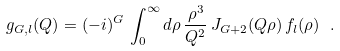Convert formula to latex. <formula><loc_0><loc_0><loc_500><loc_500>g _ { G , l } ( Q ) = ( - i ) ^ { G } \, \int _ { 0 } ^ { \infty } d \rho \, \frac { \rho ^ { 3 } } { Q ^ { 2 } } \, J _ { G + 2 } ( Q \rho ) \, f _ { l } ( \rho ) \ .</formula> 